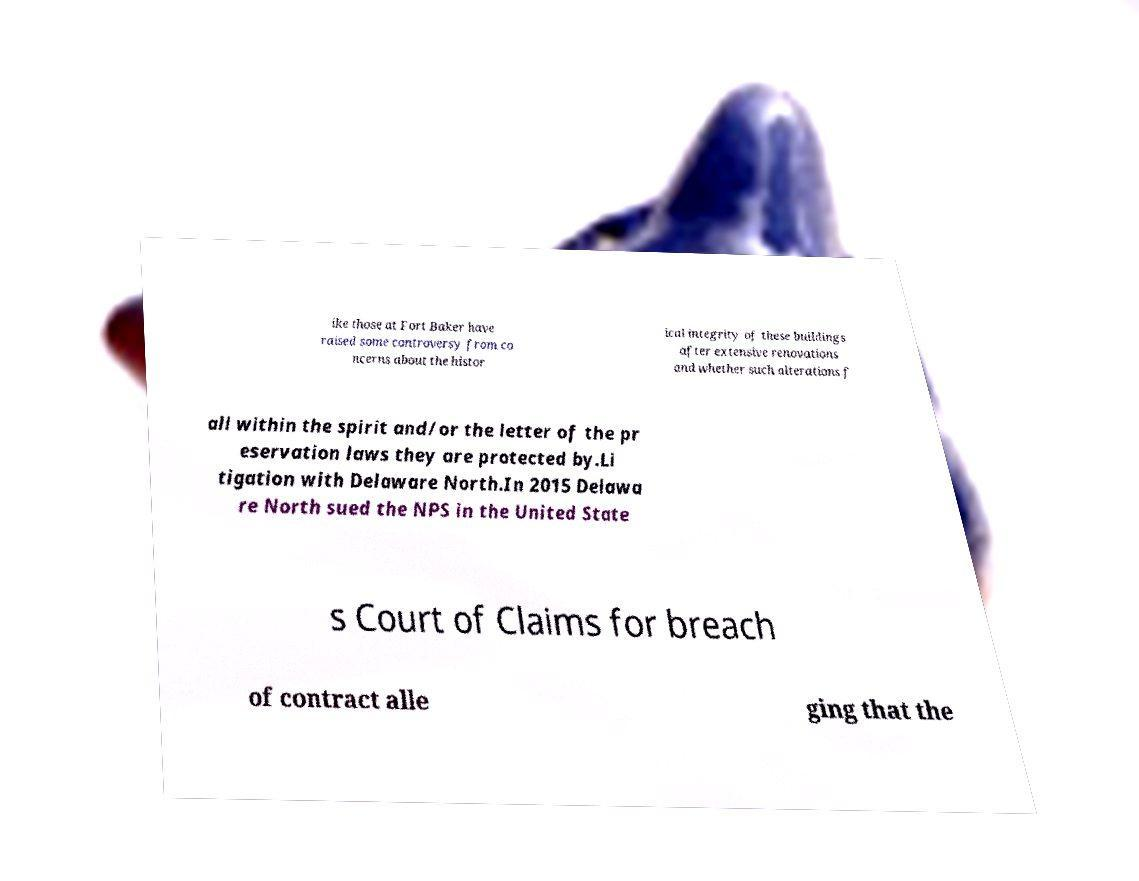There's text embedded in this image that I need extracted. Can you transcribe it verbatim? ike those at Fort Baker have raised some controversy from co ncerns about the histor ical integrity of these buildings after extensive renovations and whether such alterations f all within the spirit and/or the letter of the pr eservation laws they are protected by.Li tigation with Delaware North.In 2015 Delawa re North sued the NPS in the United State s Court of Claims for breach of contract alle ging that the 